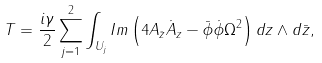<formula> <loc_0><loc_0><loc_500><loc_500>T = \frac { i \gamma } { 2 } \sum _ { j = 1 } ^ { 2 } \int _ { U _ { j } } I m \left ( 4 A _ { \bar { z } } \dot { A } _ { z } - \bar { \phi } \dot { \phi } \Omega ^ { 2 } \right ) d z \wedge d \bar { z } ,</formula> 